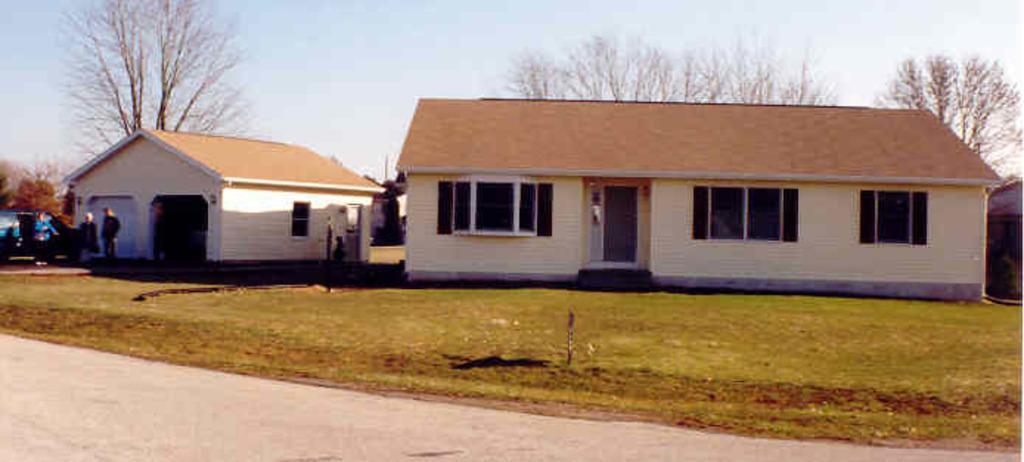Can you describe this image briefly? This image consists of houses. At the bottom, there is green grass and a road. To the left, there are three persons standing beside the vehicle. In the background, there are trees. 